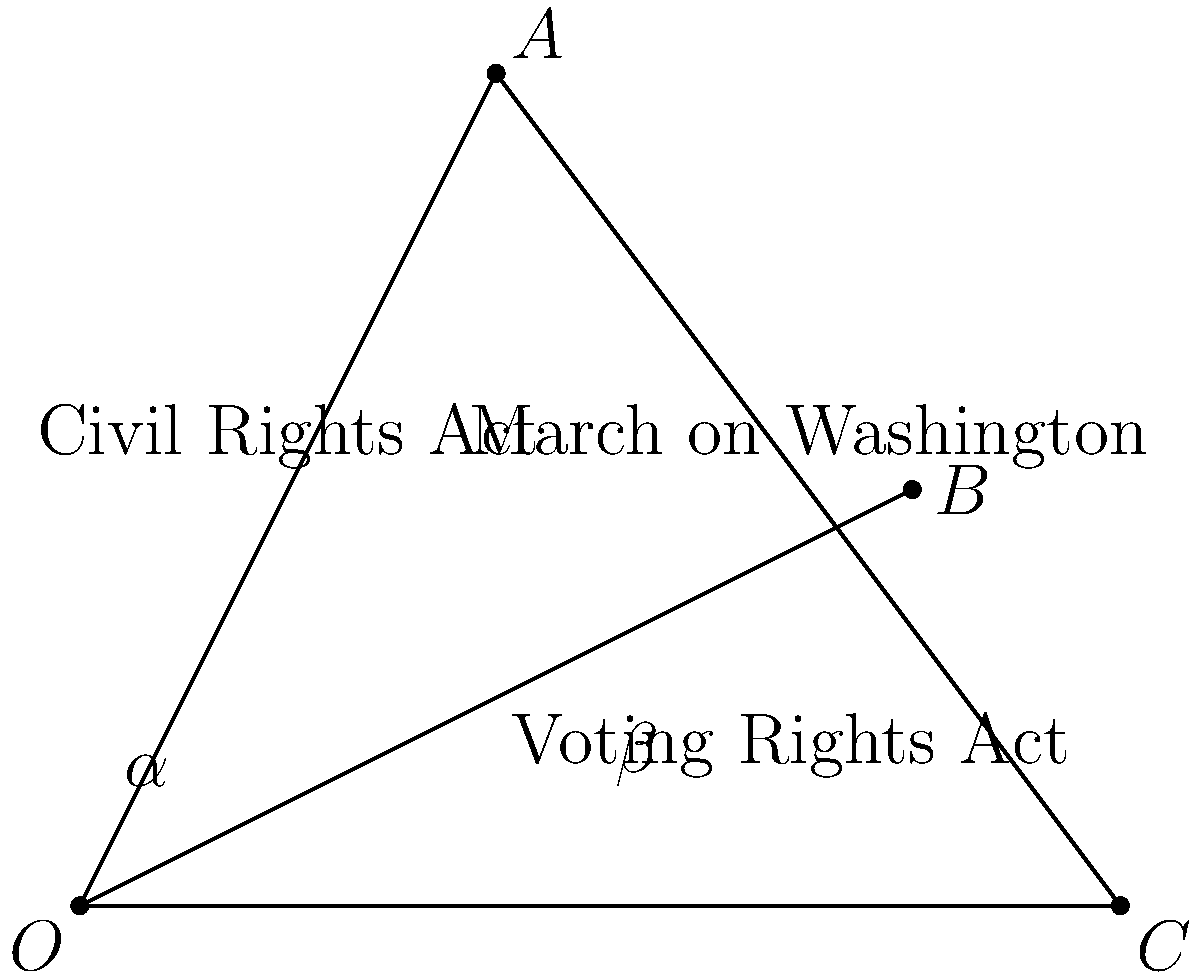In this timeline of civil rights events, the angle $\alpha$ represents the time between the Civil Rights Act and the Voting Rights Act, while angle $\beta$ represents the time between the Voting Rights Act and the March on Washington. If $\angle AOB = 60°$ and $\angle BOC = 30°$, what is the value of $\alpha + \beta$? Let's approach this step-by-step:

1) In a triangle, the sum of all interior angles is always 180°.

2) In triangle AOC:
   $\angle AOC + \angle OAC + \angle OCA = 180°$

3) We know that $\angle AOC = \angle AOB + \angle BOC = 60° + 30° = 90°$

4) Let's call $\angle OAC = x$ and $\angle OCA = y$

5) From steps 2 and 3:
   $90° + x + y = 180°$
   $x + y = 90°$

6) Now, $\alpha = \angle AOB = 60°$
   and $\beta = \angle BOC = 30°$

7) We can see that $x = 180° - \alpha - y$ and $y = 180° - \beta - x$

8) Substituting these into the equation from step 5:
   $(180° - \alpha - y) + y = 90°$
   $180° - \alpha = 90°$
   $\alpha = 90°$

9) Similarly:
   $x + (180° - \beta - x) = 90°$
   $180° - \beta = 90°$
   $\beta = 90°$

10) Therefore, $\alpha + \beta = 90° + 90° = 180°$
Answer: $180°$ 